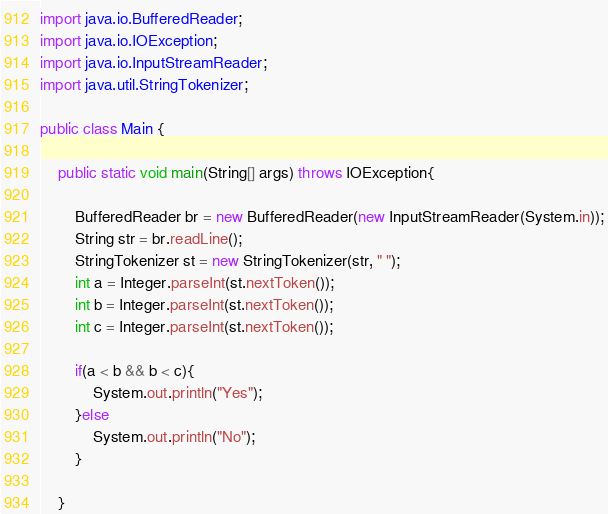Convert code to text. <code><loc_0><loc_0><loc_500><loc_500><_Java_>import java.io.BufferedReader;
import java.io.IOException;
import java.io.InputStreamReader;
import java.util.StringTokenizer;

public class Main {

	public static void main(String[] args) throws IOException{

		BufferedReader br = new BufferedReader(new InputStreamReader(System.in));
		String str = br.readLine();
		StringTokenizer st = new StringTokenizer(str, " ");
		int a = Integer.parseInt(st.nextToken());
		int b = Integer.parseInt(st.nextToken());
		int c = Integer.parseInt(st.nextToken());

		if(a < b && b < c){
			System.out.println("Yes");
		}else
			System.out.println("No");
		}

	}

</code> 